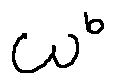<formula> <loc_0><loc_0><loc_500><loc_500>w ^ { b }</formula> 